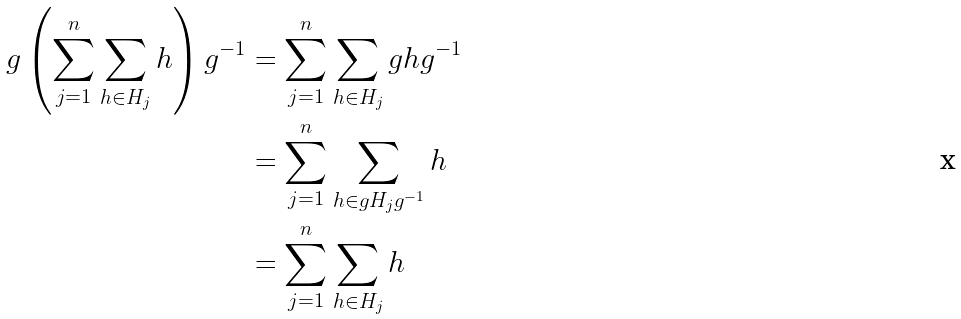<formula> <loc_0><loc_0><loc_500><loc_500>g \left ( \sum _ { j = 1 } ^ { n } \sum _ { h \in H _ { j } } h \right ) g ^ { - 1 } & = \sum _ { j = 1 } ^ { n } \sum _ { h \in H _ { j } } g h g ^ { - 1 } \\ & = \sum _ { j = 1 } ^ { n } \sum _ { h \in g H _ { j } g ^ { - 1 } } h \\ & = \sum _ { j = 1 } ^ { n } \sum _ { h \in H _ { j } } h</formula> 